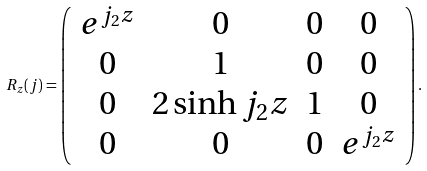Convert formula to latex. <formula><loc_0><loc_0><loc_500><loc_500>R _ { z } ( { j } ) = \left ( \begin{array} { c c c c } e ^ { j _ { 2 } z } & 0 & 0 & 0 \\ 0 & 1 & 0 & 0 \\ 0 & 2 \sinh { j _ { 2 } z } & 1 & 0 \\ 0 & 0 & 0 & e ^ { j _ { 2 } z } \end{array} \right ) .</formula> 